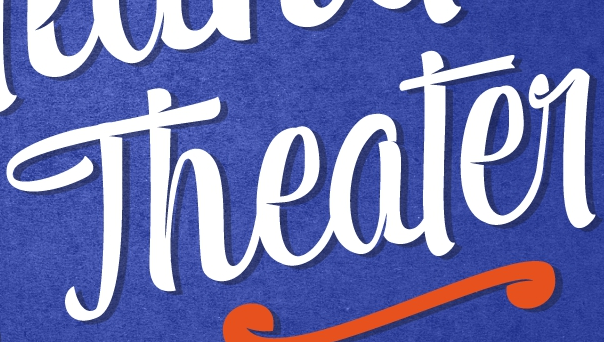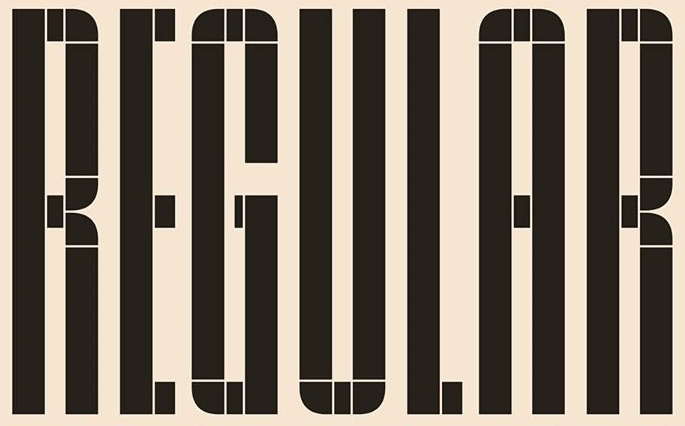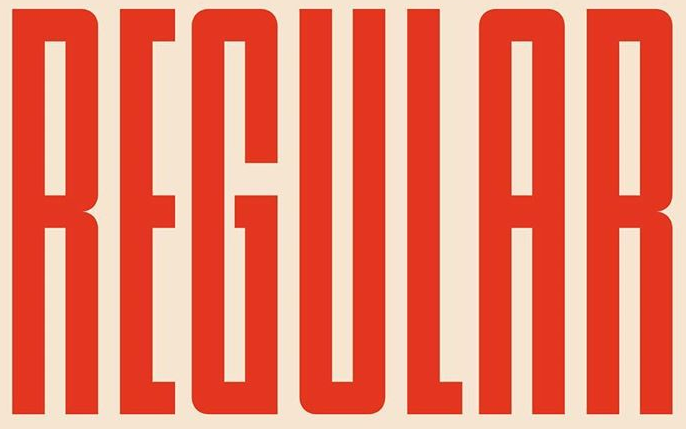Transcribe the words shown in these images in order, separated by a semicolon. Theater; REGULAR; REGULAR 